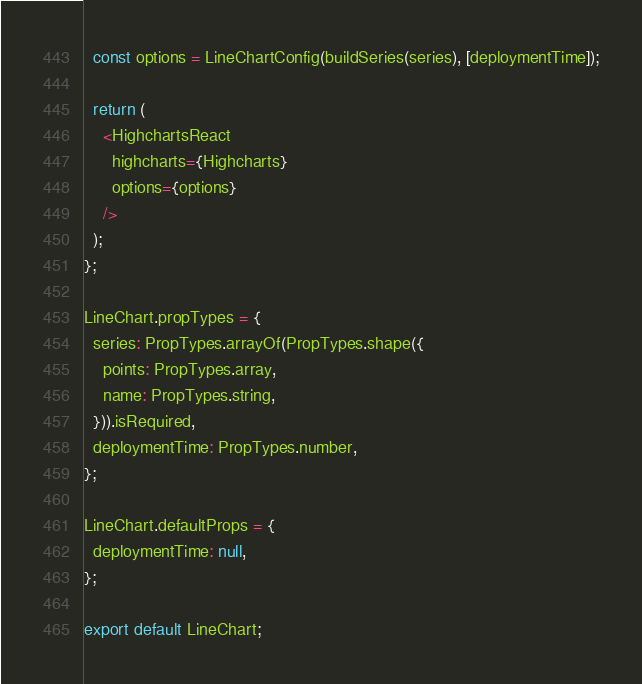<code> <loc_0><loc_0><loc_500><loc_500><_JavaScript_>  const options = LineChartConfig(buildSeries(series), [deploymentTime]);

  return (
    <HighchartsReact
      highcharts={Highcharts}
      options={options}
    />
  );
};

LineChart.propTypes = {
  series: PropTypes.arrayOf(PropTypes.shape({
    points: PropTypes.array,
    name: PropTypes.string,
  })).isRequired,
  deploymentTime: PropTypes.number,
};

LineChart.defaultProps = {
  deploymentTime: null,
};

export default LineChart;
</code> 